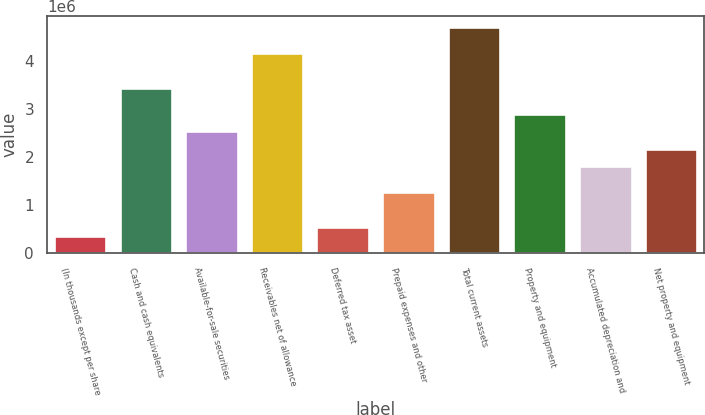<chart> <loc_0><loc_0><loc_500><loc_500><bar_chart><fcel>(In thousands except per share<fcel>Cash and cash equivalents<fcel>Available-for-sale securities<fcel>Receivables net of allowance<fcel>Deferred tax asset<fcel>Prepaid expenses and other<fcel>Total current assets<fcel>Property and equipment<fcel>Accumulated depreciation and<fcel>Net property and equipment<nl><fcel>362472<fcel>3.44125e+06<fcel>2.53572e+06<fcel>4.16566e+06<fcel>543576<fcel>1.26799e+06<fcel>4.70898e+06<fcel>2.89793e+06<fcel>1.81131e+06<fcel>2.17352e+06<nl></chart> 